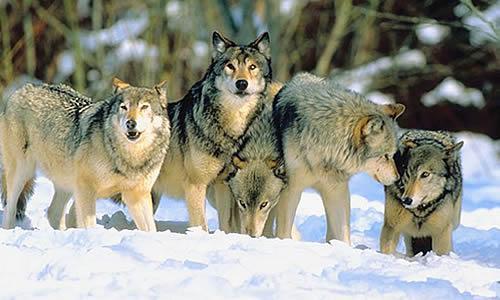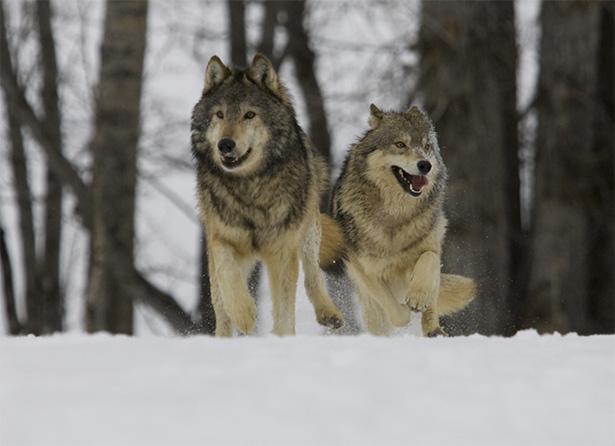The first image is the image on the left, the second image is the image on the right. Assess this claim about the two images: "Three wild dogs are in the snow in the image on the left.". Correct or not? Answer yes or no. No. 